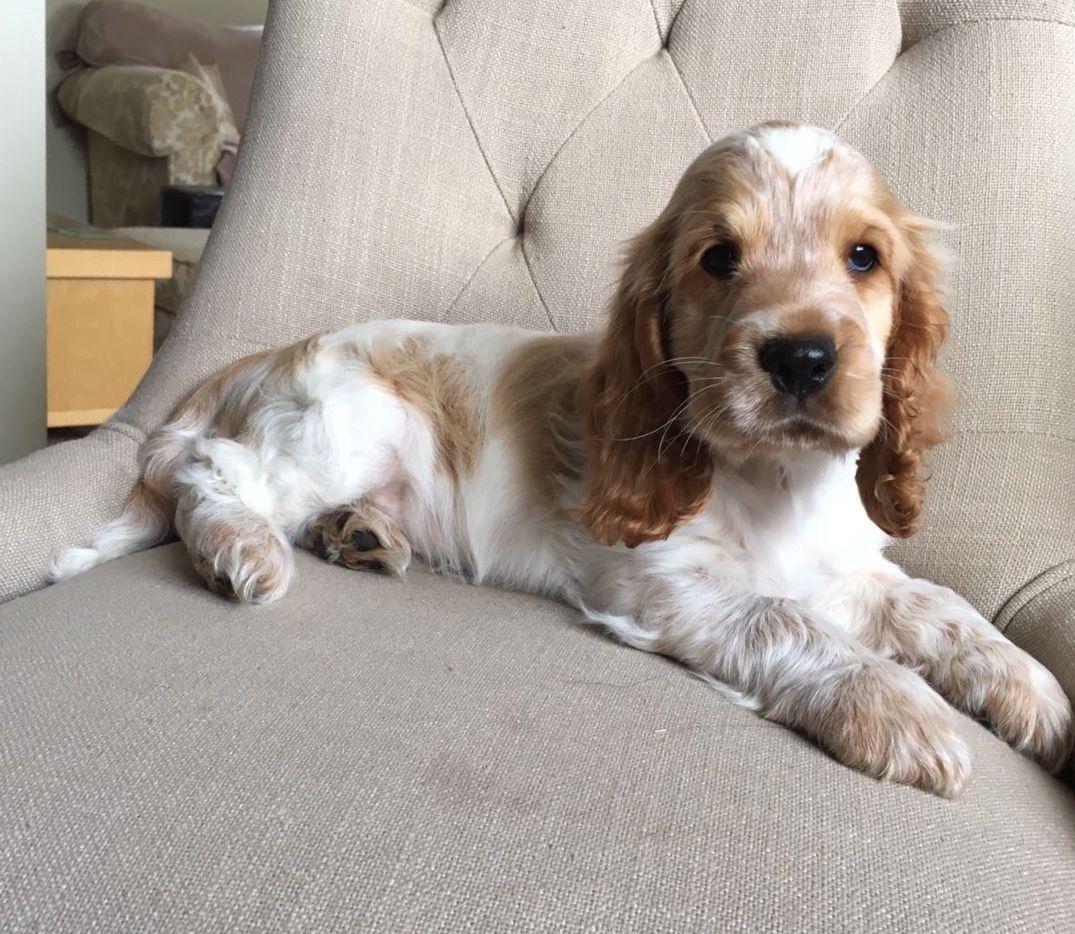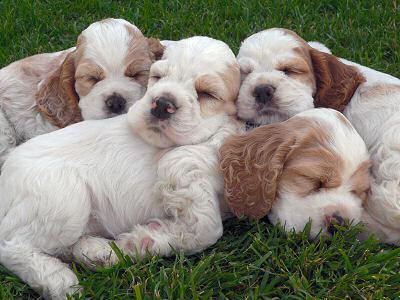The first image is the image on the left, the second image is the image on the right. Analyze the images presented: Is the assertion "The dogs in all of the images are indoors." valid? Answer yes or no. No. The first image is the image on the left, the second image is the image on the right. For the images displayed, is the sentence "The right image features at least one spaniel posed on green grass, and the left image contains just one spaniel, which is white with light orange markings." factually correct? Answer yes or no. Yes. 